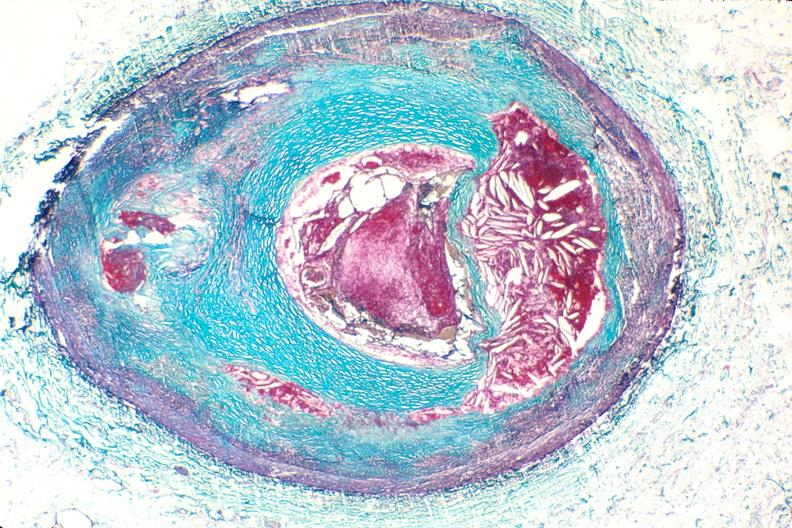where is this from?
Answer the question using a single word or phrase. Vasculature 